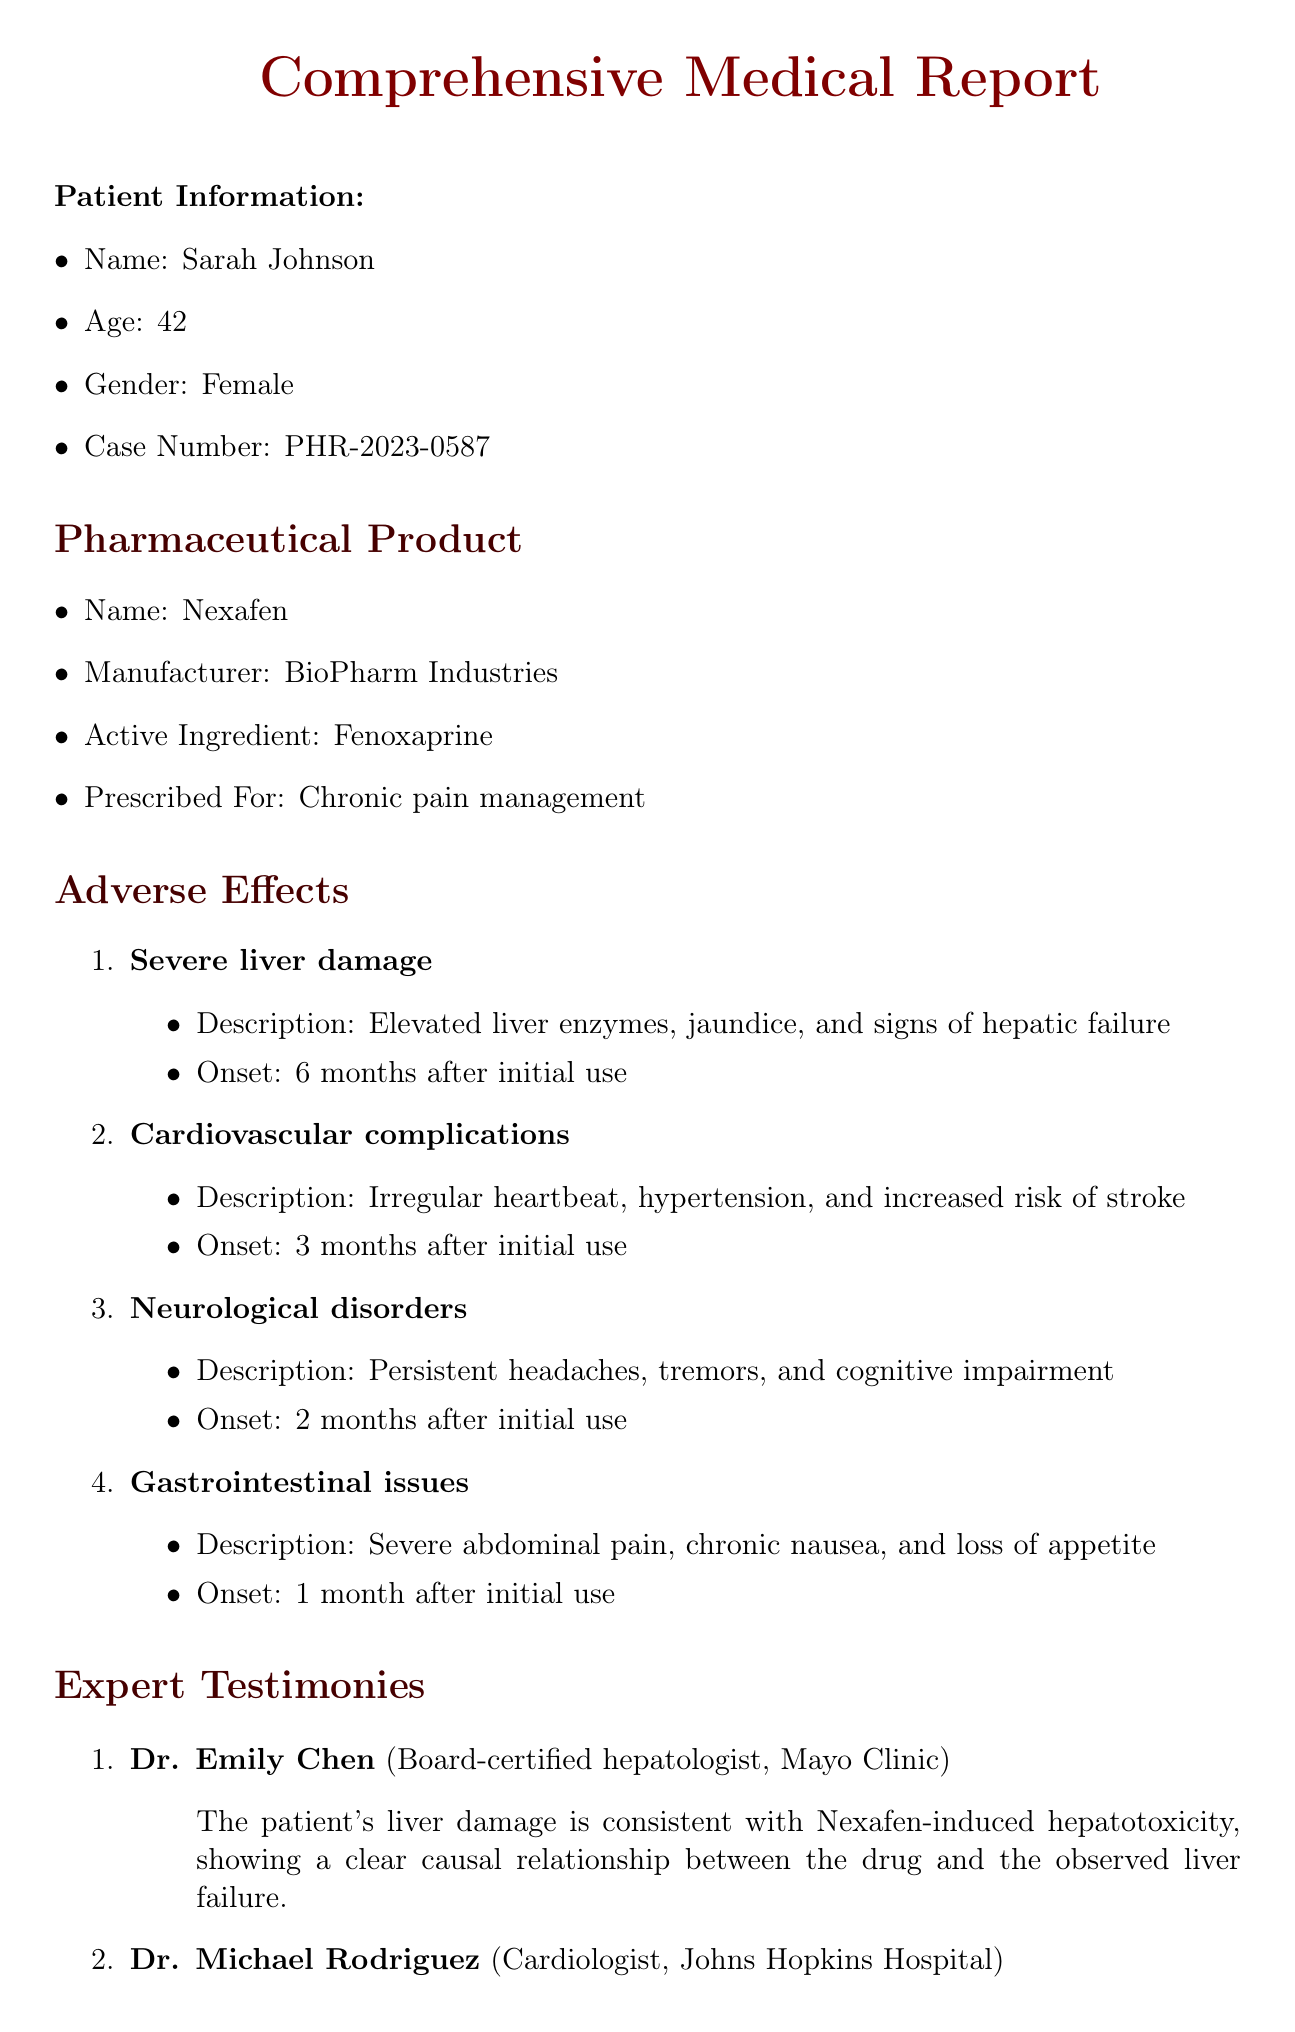What is the name of the patient? The name of the patient is provided in the patient information section of the document.
Answer: Sarah Johnson What is the active ingredient in Nexafen? The active ingredient is listed under the pharmaceutical product section.
Answer: Fenoxaprine What severe adverse effect occurred 6 months after initial use? This effect is mentioned under the adverse effects section with specific timing.
Answer: Severe liver damage Who is the expert witness for liver damage? The expert testimonies section lists the professionals and their specialties.
Answer: Dr. Emily Chen What long-term implication may require a transplant? This implication is listed in the long-term implications section of the document.
Answer: Permanent liver damage How many months after use did neurological disorders onset? The onset time for neurological disorders is specified in the adverse effects section.
Answer: 2 months What is a recommended action related to cardiovascular health? This action can be found in the recommended actions section of the document.
Answer: Cardiovascular rehabilitation What is the case number associated with this report? The case number is clearly stated in the patient information section.
Answer: PHR-2023-0587 What type of complications are linked to Fenoxaprine? The connection between complications and the active ingredient is mentioned in the expert testimonies.
Answer: Cardiovascular complications 